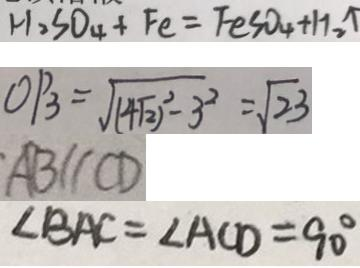<formula> <loc_0><loc_0><loc_500><loc_500>H _ { 2 } S O _ { 4 } + F e = F e S O _ { 4 } + H _ { 2 } \uparrow 
 O P _ { 3 } = \sqrt { ( 4 \sqrt { 2 } ) ^ { 2 } - 3 ^ { 2 } } = \sqrt { 2 3 } 
 A B / / C D 
 \angle B A C = \angle A C D = 9 0 ^ { \circ }</formula> 